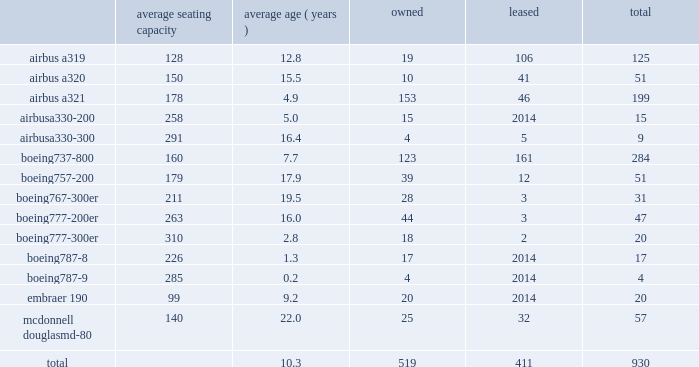Table of contents item 2 .
Properties flight equipment and fleet renewal as of december 31 , 2016 , american operated a mainline fleet of 930 aircraft .
In 2016 , we continued our extensive fleet renewal program , which has provided us with the youngest fleet of the major u.s .
Network carriers .
During 2016 , american took delivery of 55 new mainline aircraft and retired 71 aircraft .
We are supported by our wholly-owned and third-party regional carriers that fly under capacity purchase agreements operating as american eagle .
As of december 31 , 2016 , american eagle operated 606 regional aircraft .
During 2016 , we increased our regional fleet by 61 regional aircraft , we removed and placed in temporary storage one embraer erj 140 aircraft and retired 41 other regional aircraft .
Mainline as of december 31 , 2016 , american 2019s mainline fleet consisted of the following aircraft : average seating capacity average ( years ) owned leased total .

What was the net change in airliner count during 2016? 
Computations: (55 - 71)
Answer: -16.0. 